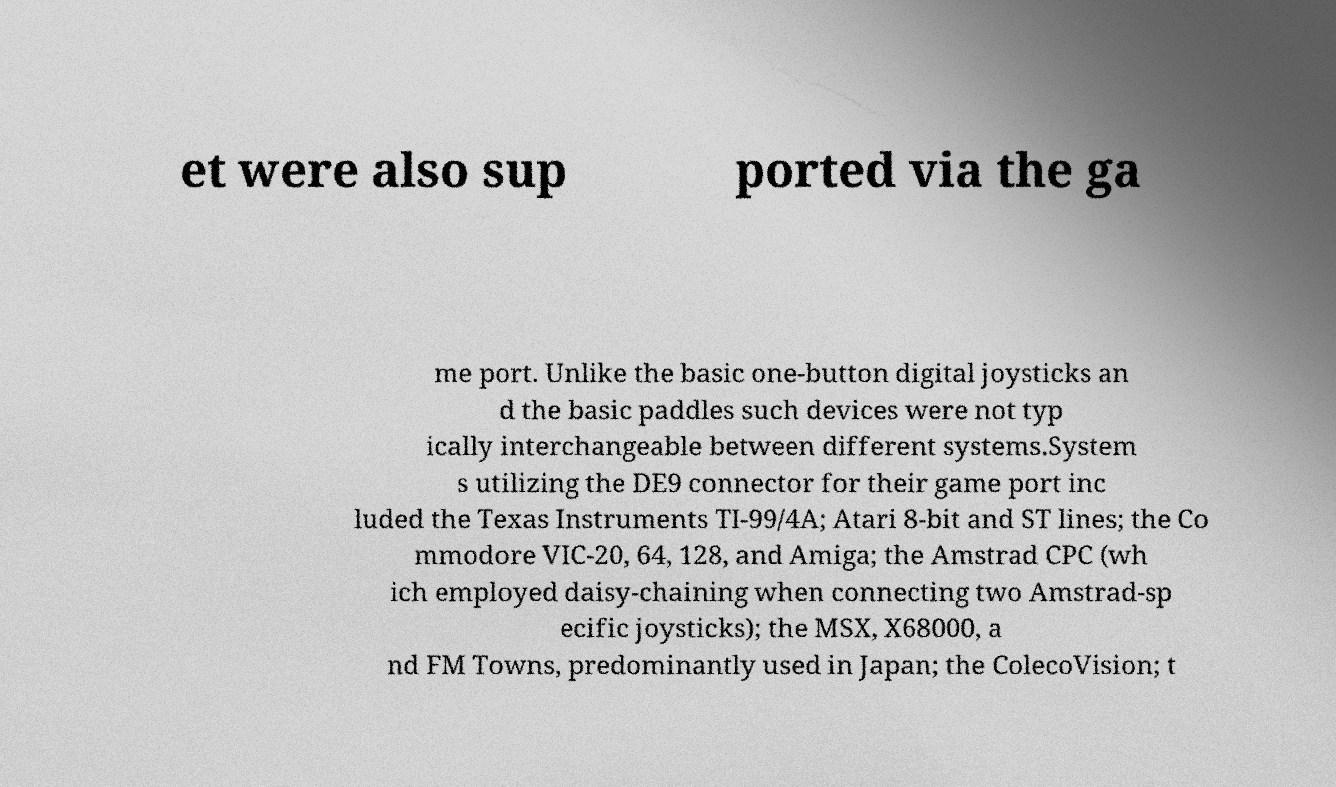Can you read and provide the text displayed in the image?This photo seems to have some interesting text. Can you extract and type it out for me? et were also sup ported via the ga me port. Unlike the basic one-button digital joysticks an d the basic paddles such devices were not typ ically interchangeable between different systems.System s utilizing the DE9 connector for their game port inc luded the Texas Instruments TI-99/4A; Atari 8-bit and ST lines; the Co mmodore VIC-20, 64, 128, and Amiga; the Amstrad CPC (wh ich employed daisy-chaining when connecting two Amstrad-sp ecific joysticks); the MSX, X68000, a nd FM Towns, predominantly used in Japan; the ColecoVision; t 